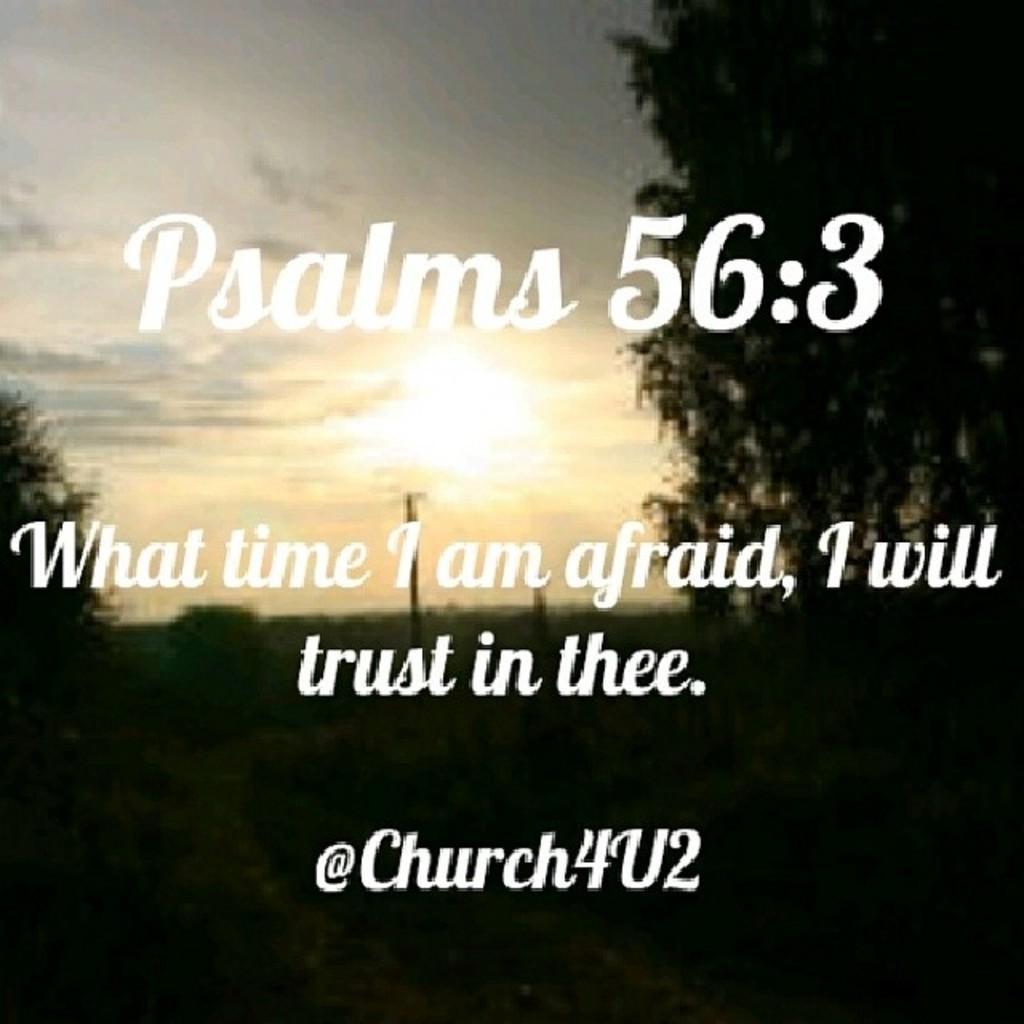In one or two sentences, can you explain what this image depicts? In this image there is the sky, there are trees, there is a tree truncated towards the right of the image, there is a tree truncated towards the left of the image, there are poles, there is text on the image. 